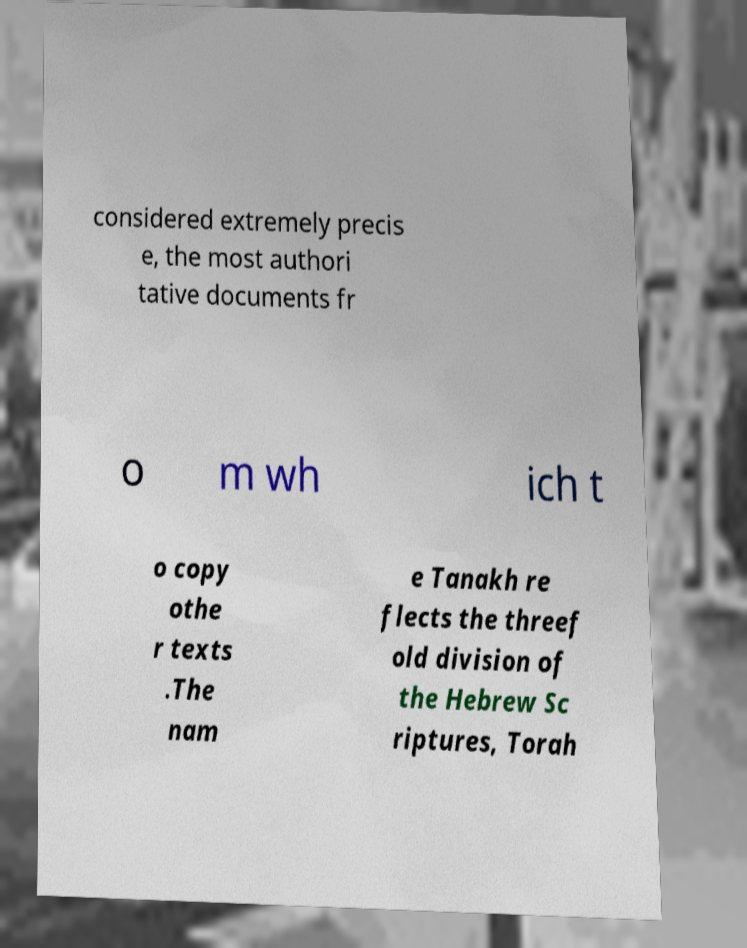Can you read and provide the text displayed in the image?This photo seems to have some interesting text. Can you extract and type it out for me? considered extremely precis e, the most authori tative documents fr o m wh ich t o copy othe r texts .The nam e Tanakh re flects the threef old division of the Hebrew Sc riptures, Torah 